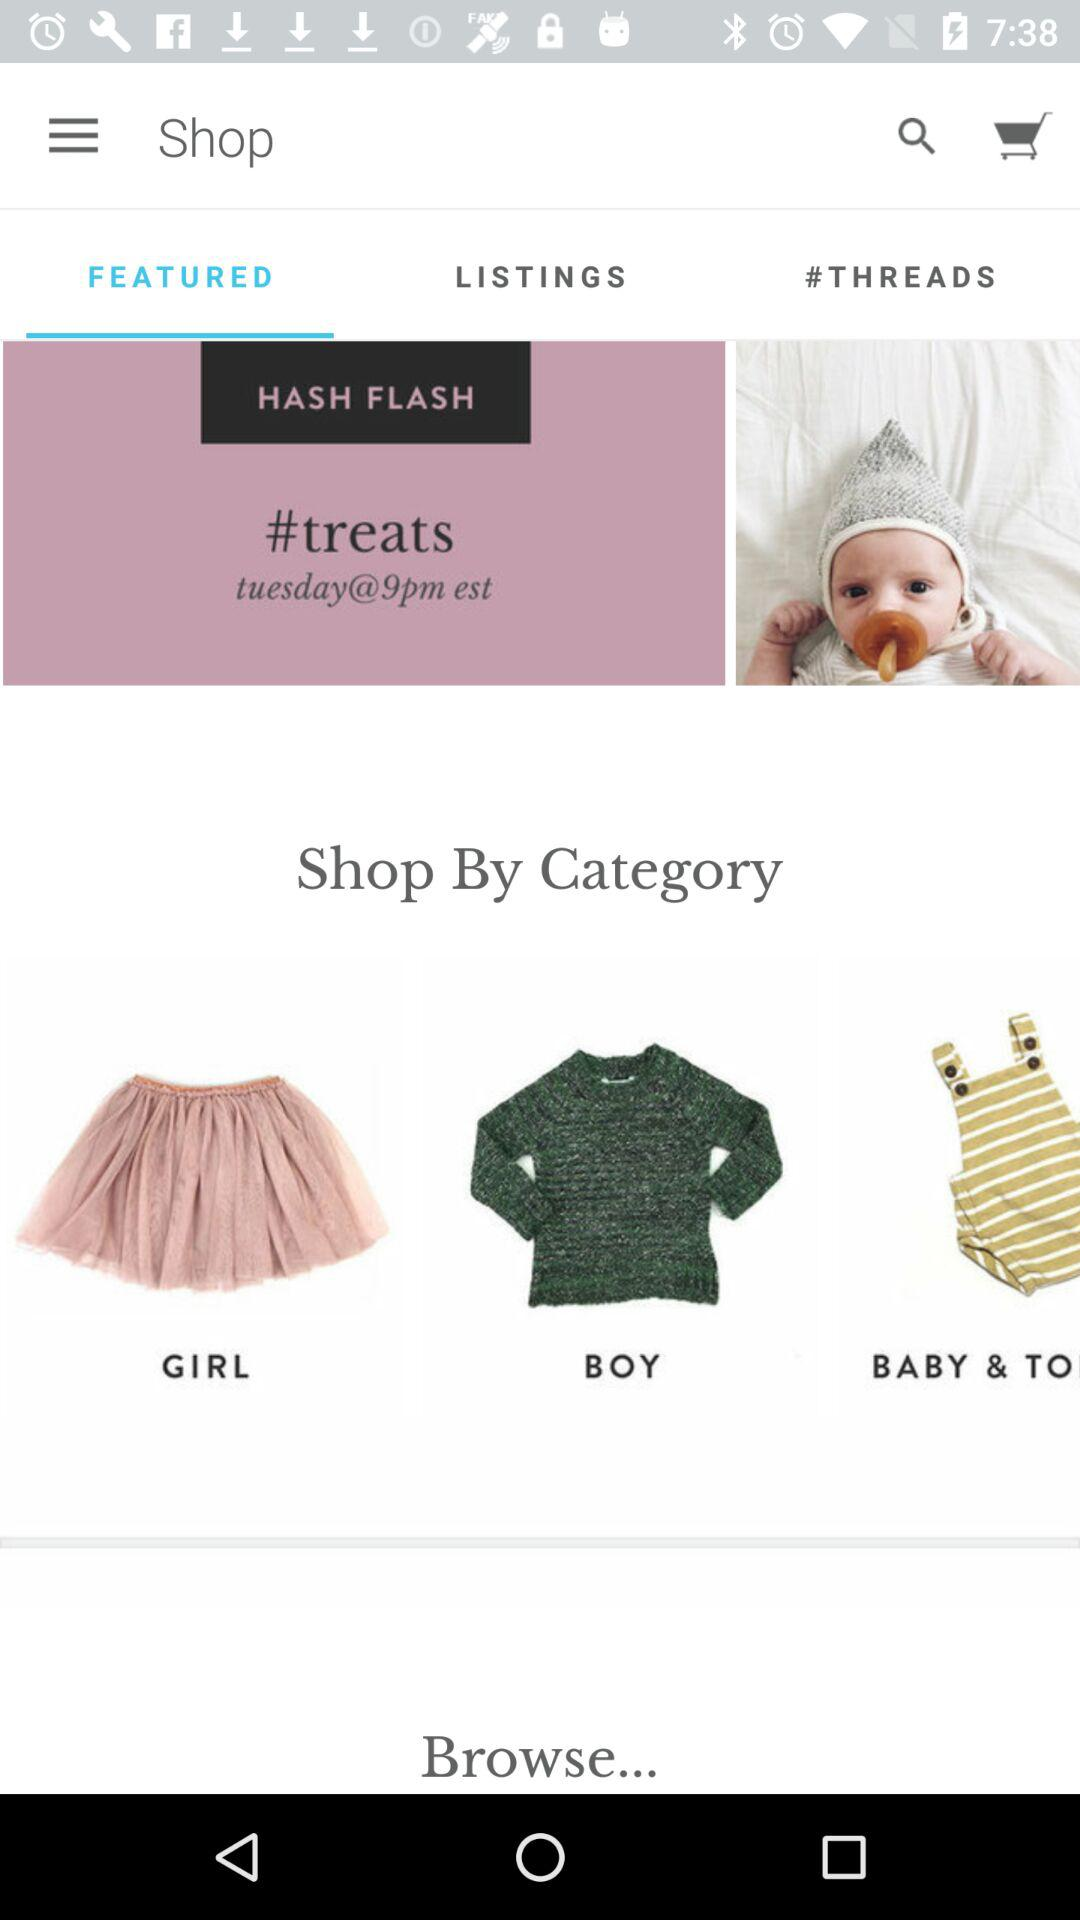Which option is selected? The selected option is "FEATURED". 